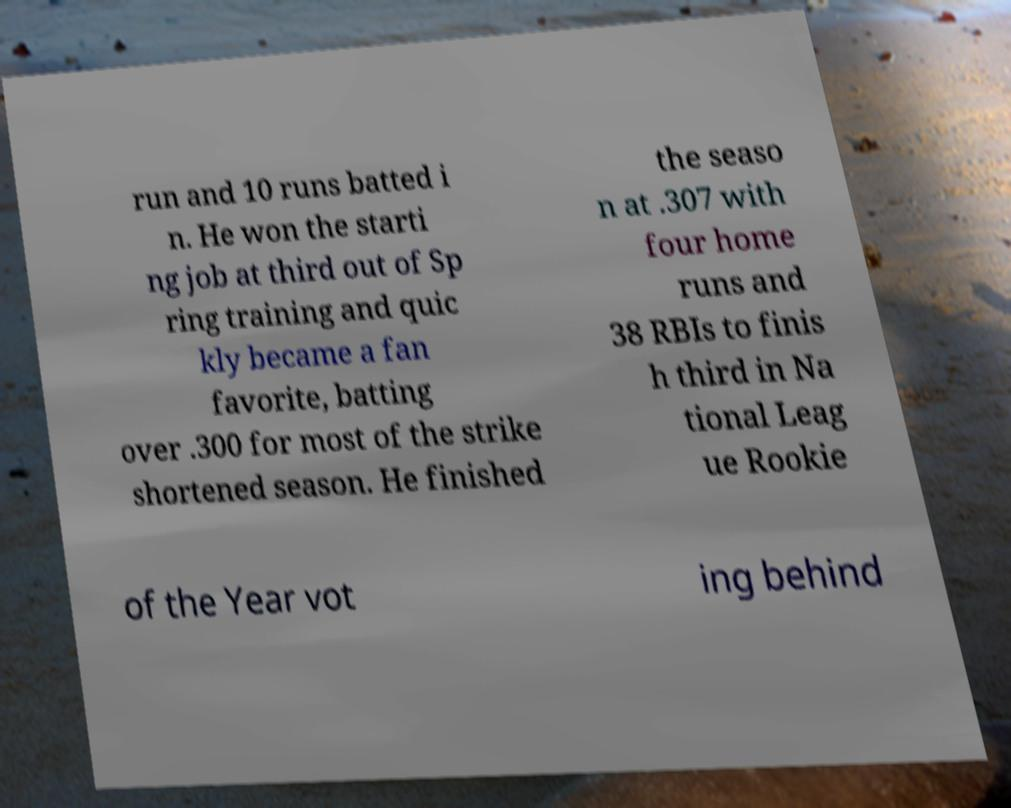There's text embedded in this image that I need extracted. Can you transcribe it verbatim? run and 10 runs batted i n. He won the starti ng job at third out of Sp ring training and quic kly became a fan favorite, batting over .300 for most of the strike shortened season. He finished the seaso n at .307 with four home runs and 38 RBIs to finis h third in Na tional Leag ue Rookie of the Year vot ing behind 